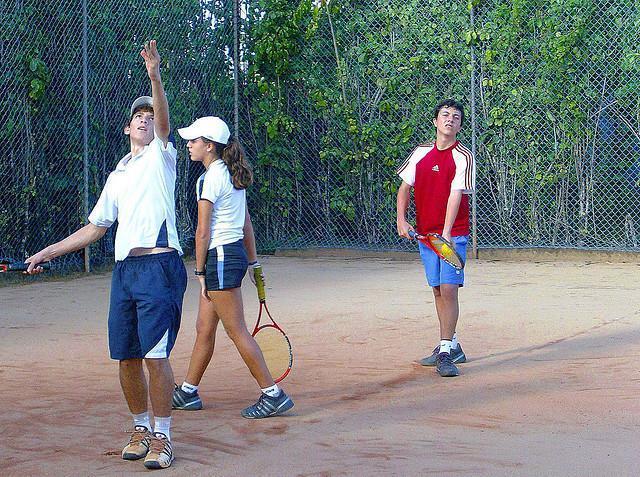How many people are there?
Give a very brief answer. 3. How many people can you see?
Give a very brief answer. 3. 